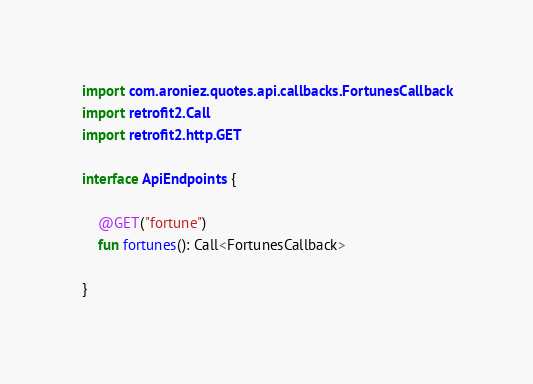Convert code to text. <code><loc_0><loc_0><loc_500><loc_500><_Kotlin_>
import com.aroniez.quotes.api.callbacks.FortunesCallback
import retrofit2.Call
import retrofit2.http.GET

interface ApiEndpoints {

    @GET("fortune")
    fun fortunes(): Call<FortunesCallback>

}
</code> 